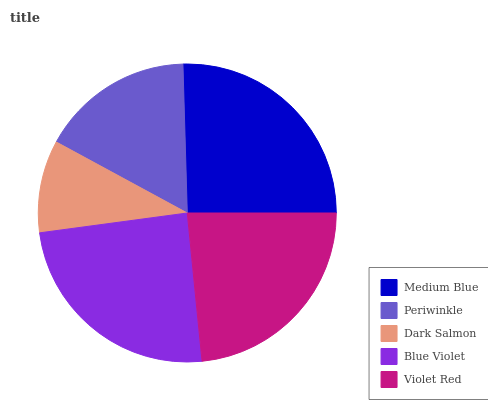Is Dark Salmon the minimum?
Answer yes or no. Yes. Is Medium Blue the maximum?
Answer yes or no. Yes. Is Periwinkle the minimum?
Answer yes or no. No. Is Periwinkle the maximum?
Answer yes or no. No. Is Medium Blue greater than Periwinkle?
Answer yes or no. Yes. Is Periwinkle less than Medium Blue?
Answer yes or no. Yes. Is Periwinkle greater than Medium Blue?
Answer yes or no. No. Is Medium Blue less than Periwinkle?
Answer yes or no. No. Is Violet Red the high median?
Answer yes or no. Yes. Is Violet Red the low median?
Answer yes or no. Yes. Is Medium Blue the high median?
Answer yes or no. No. Is Blue Violet the low median?
Answer yes or no. No. 